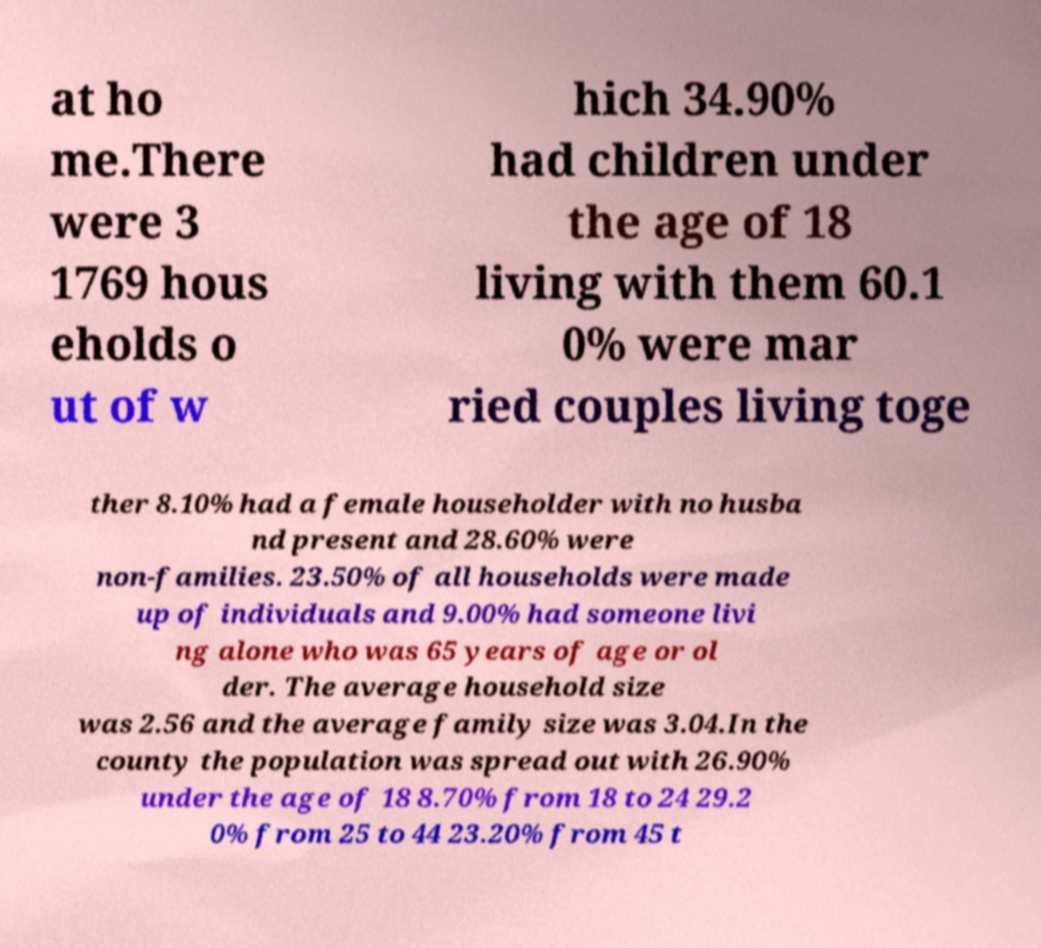Could you extract and type out the text from this image? at ho me.There were 3 1769 hous eholds o ut of w hich 34.90% had children under the age of 18 living with them 60.1 0% were mar ried couples living toge ther 8.10% had a female householder with no husba nd present and 28.60% were non-families. 23.50% of all households were made up of individuals and 9.00% had someone livi ng alone who was 65 years of age or ol der. The average household size was 2.56 and the average family size was 3.04.In the county the population was spread out with 26.90% under the age of 18 8.70% from 18 to 24 29.2 0% from 25 to 44 23.20% from 45 t 